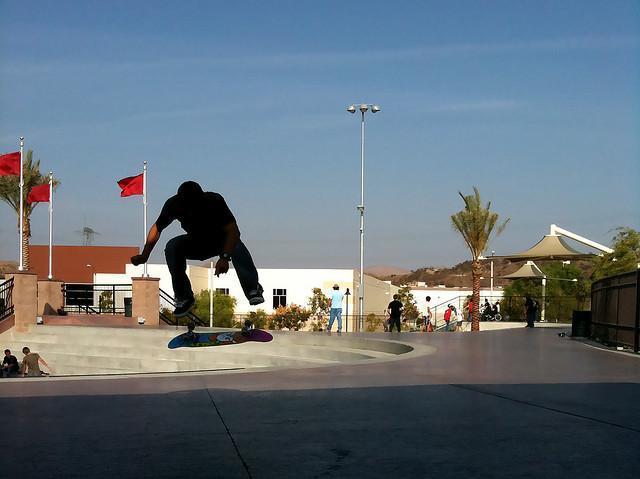How many flags are visible?
Give a very brief answer. 3. How many flags are in the picture?
Give a very brief answer. 3. How many people are to the left of the man with an umbrella over his head?
Give a very brief answer. 0. 